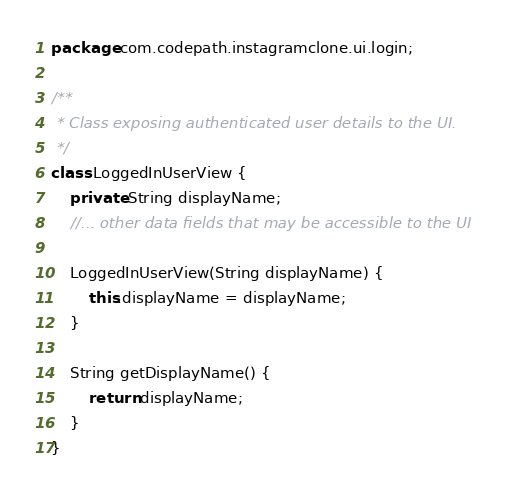<code> <loc_0><loc_0><loc_500><loc_500><_Java_>package com.codepath.instagramclone.ui.login;

/**
 * Class exposing authenticated user details to the UI.
 */
class LoggedInUserView {
    private String displayName;
    //... other data fields that may be accessible to the UI

    LoggedInUserView(String displayName) {
        this.displayName = displayName;
    }

    String getDisplayName() {
        return displayName;
    }
}
</code> 